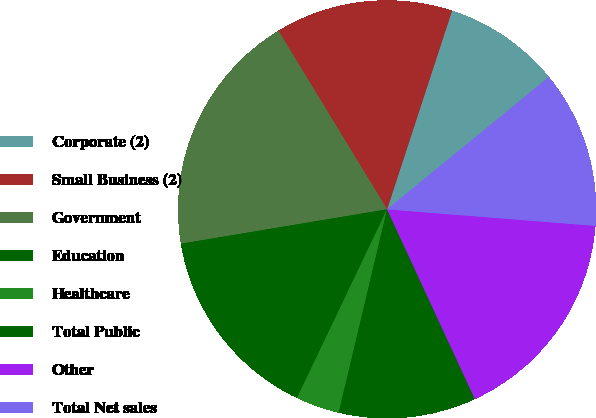<chart> <loc_0><loc_0><loc_500><loc_500><pie_chart><fcel>Corporate (2)<fcel>Small Business (2)<fcel>Government<fcel>Education<fcel>Healthcare<fcel>Total Public<fcel>Other<fcel>Total Net sales<nl><fcel>9.06%<fcel>13.73%<fcel>18.93%<fcel>15.28%<fcel>3.37%<fcel>10.62%<fcel>16.84%<fcel>12.17%<nl></chart> 